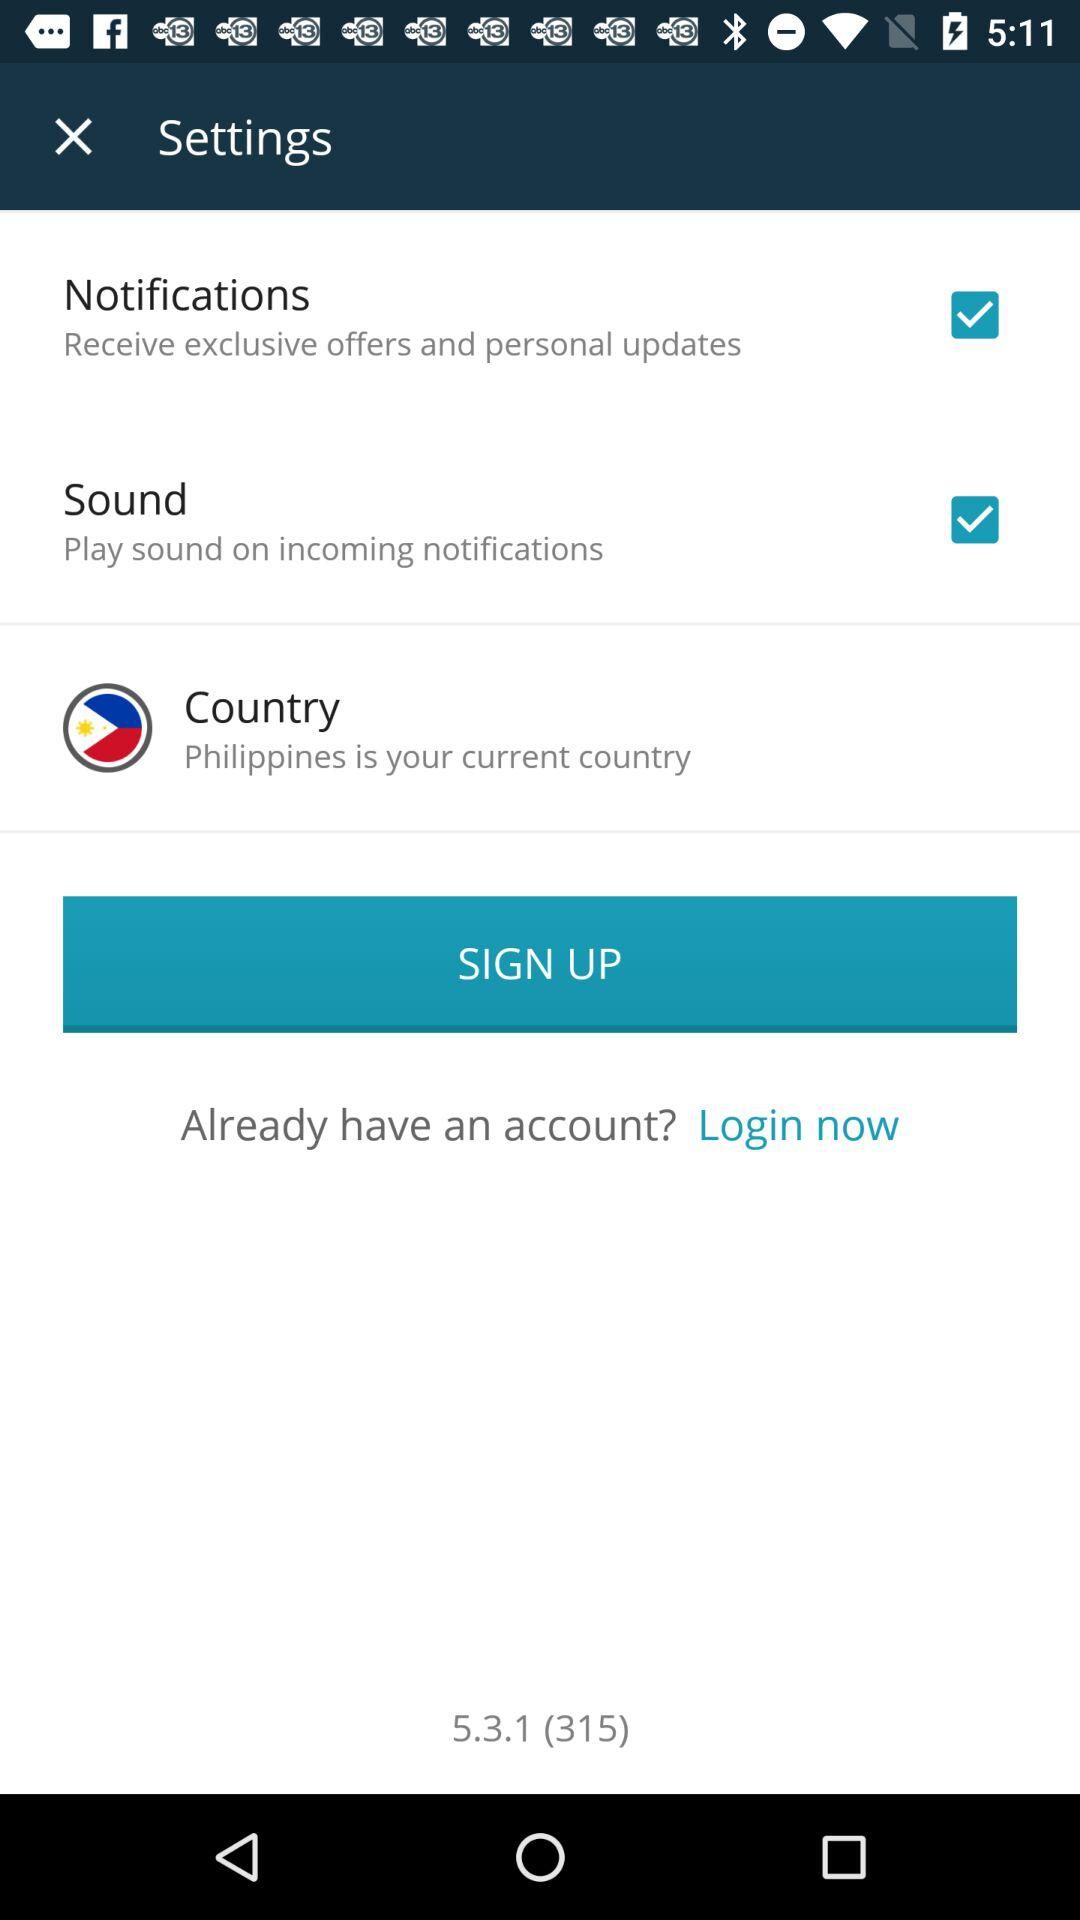What is the current country? The current country is the Philippines. 